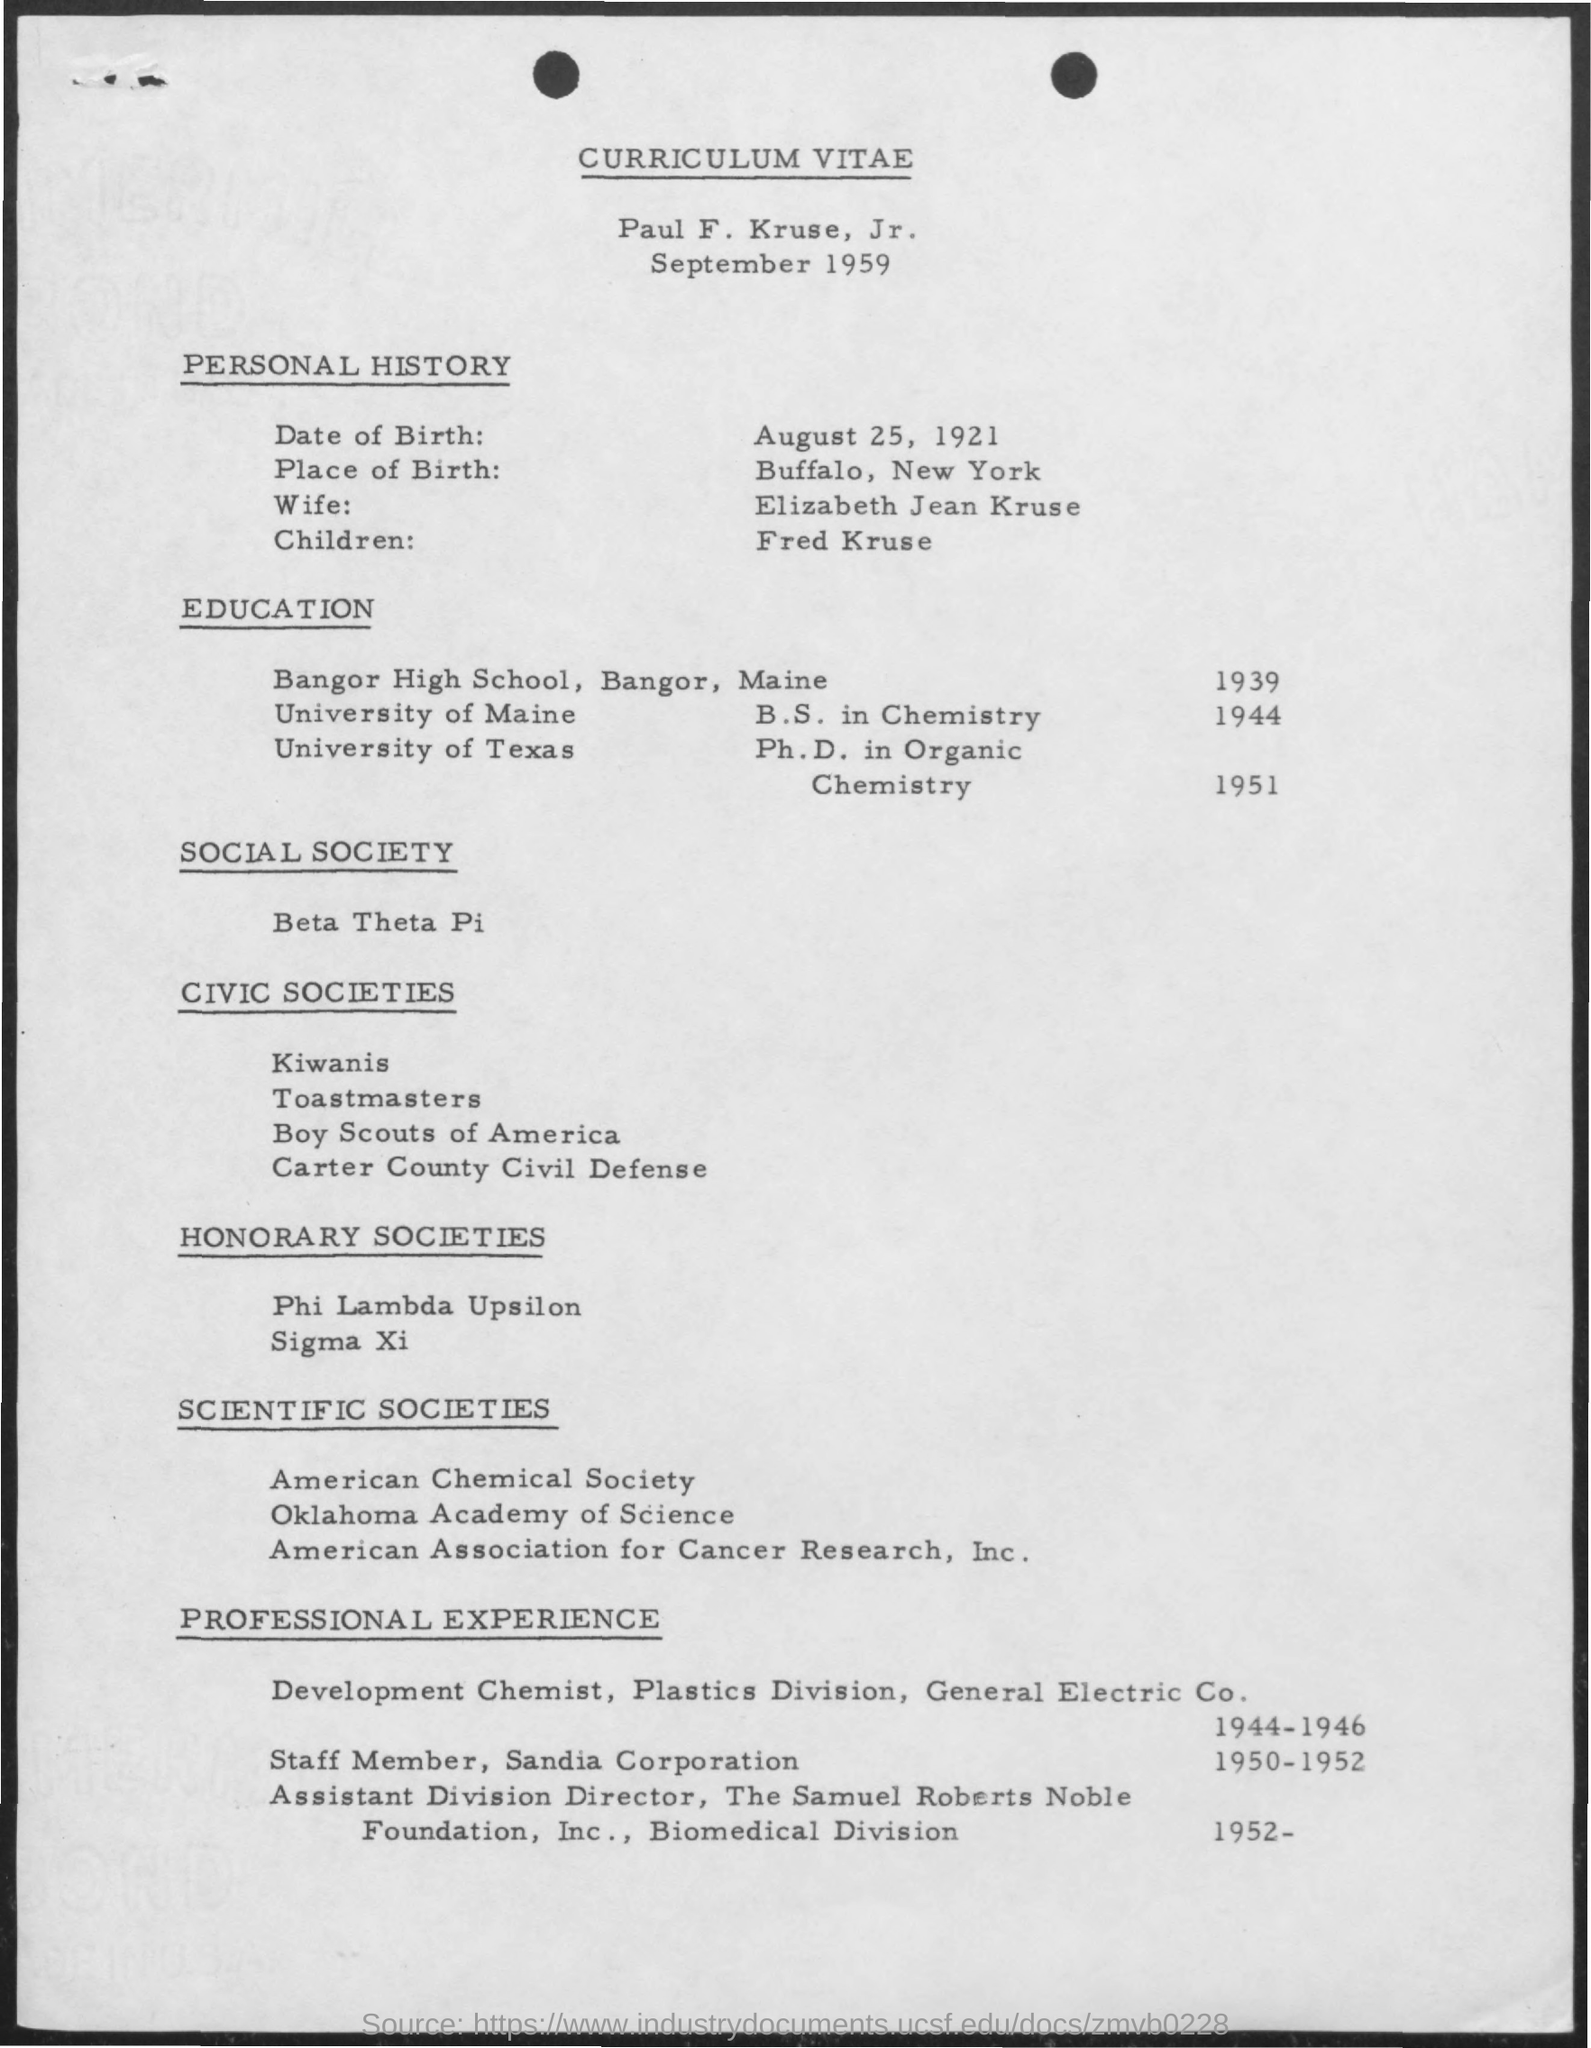Which University he completed Ph.D?
Your answer should be compact. University of Texas. Which year he completed Ph.D?
Make the answer very short. 1951. What is his wife name?
Offer a very short reply. Elizabeth Jean Kruse. 